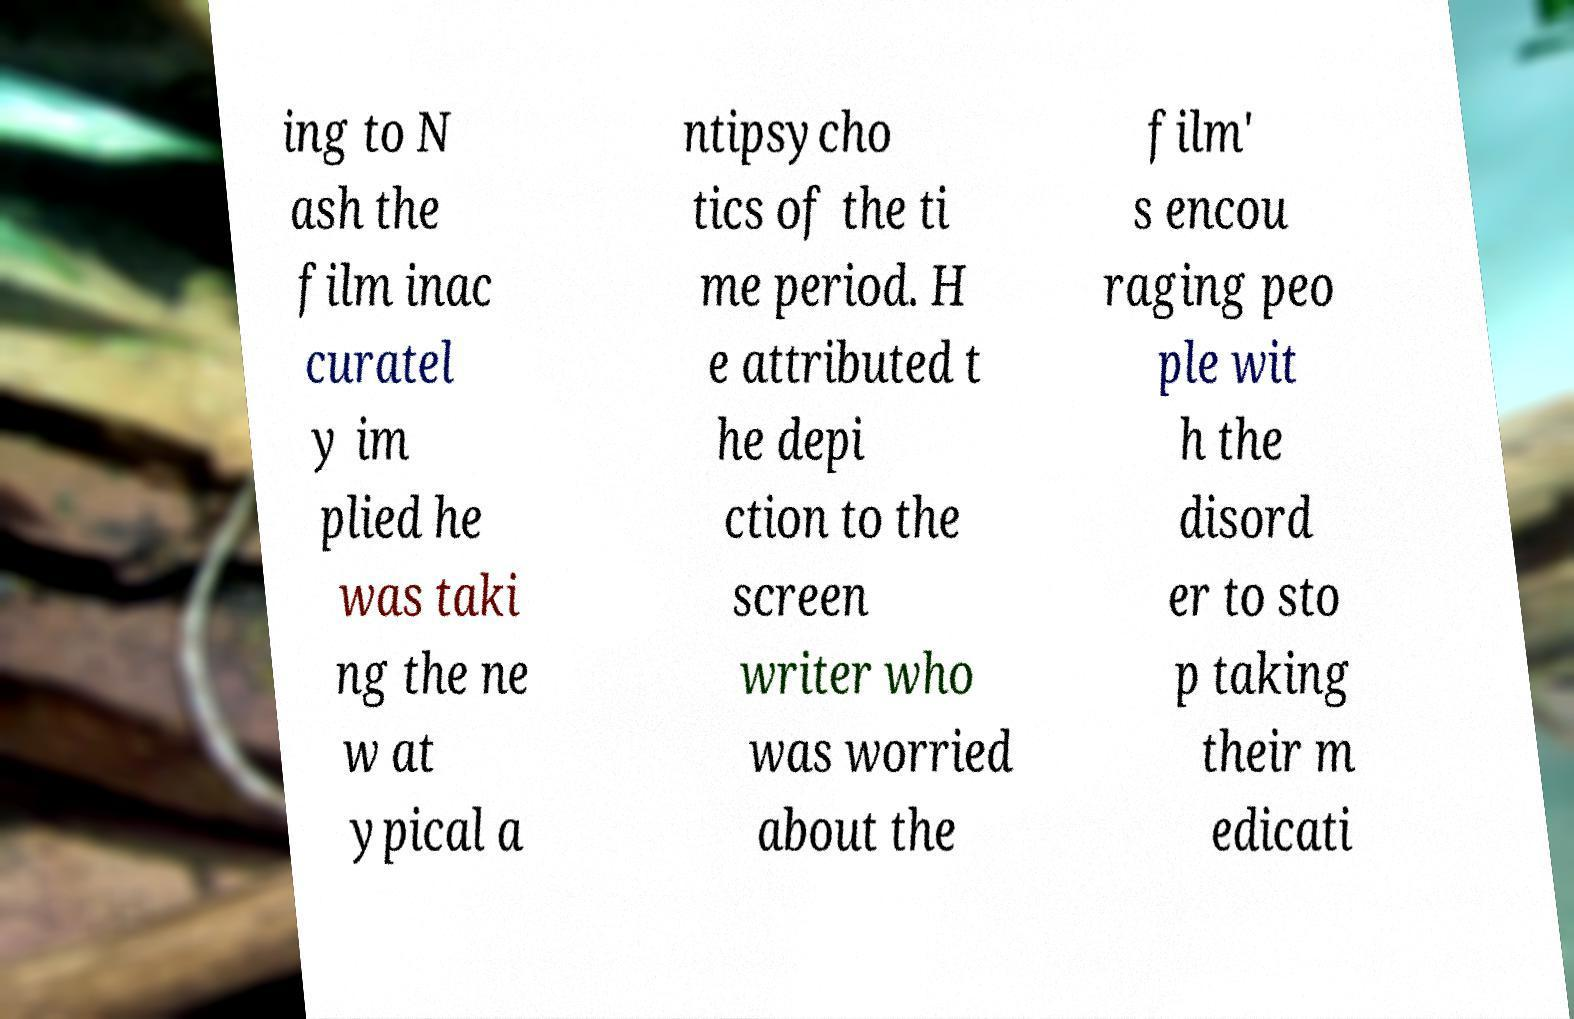Could you assist in decoding the text presented in this image and type it out clearly? ing to N ash the film inac curatel y im plied he was taki ng the ne w at ypical a ntipsycho tics of the ti me period. H e attributed t he depi ction to the screen writer who was worried about the film' s encou raging peo ple wit h the disord er to sto p taking their m edicati 